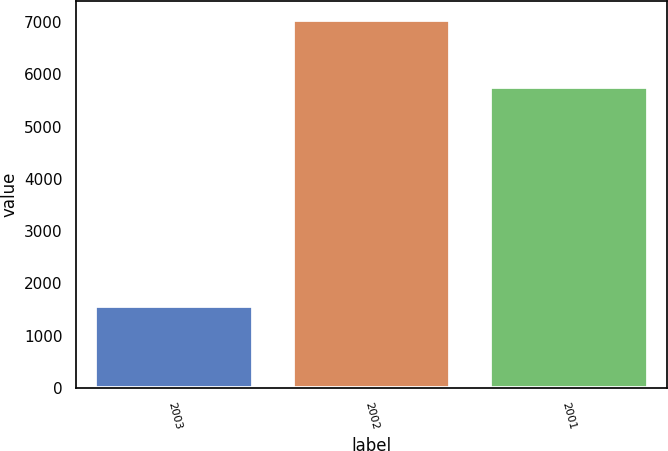<chart> <loc_0><loc_0><loc_500><loc_500><bar_chart><fcel>2003<fcel>2002<fcel>2001<nl><fcel>1577<fcel>7042<fcel>5759<nl></chart> 